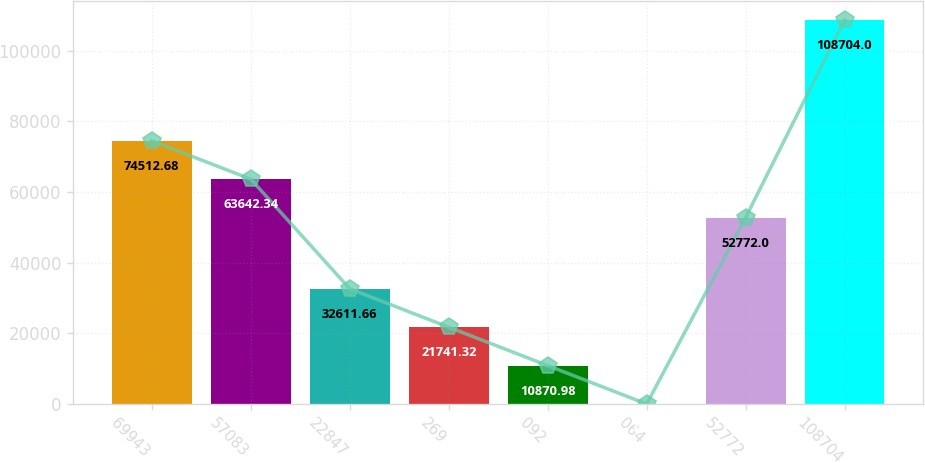Convert chart to OTSL. <chart><loc_0><loc_0><loc_500><loc_500><bar_chart><fcel>69943<fcel>57083<fcel>22847<fcel>269<fcel>092<fcel>064<fcel>52772<fcel>108704<nl><fcel>74512.7<fcel>63642.3<fcel>32611.7<fcel>21741.3<fcel>10871<fcel>0.64<fcel>52772<fcel>108704<nl></chart> 